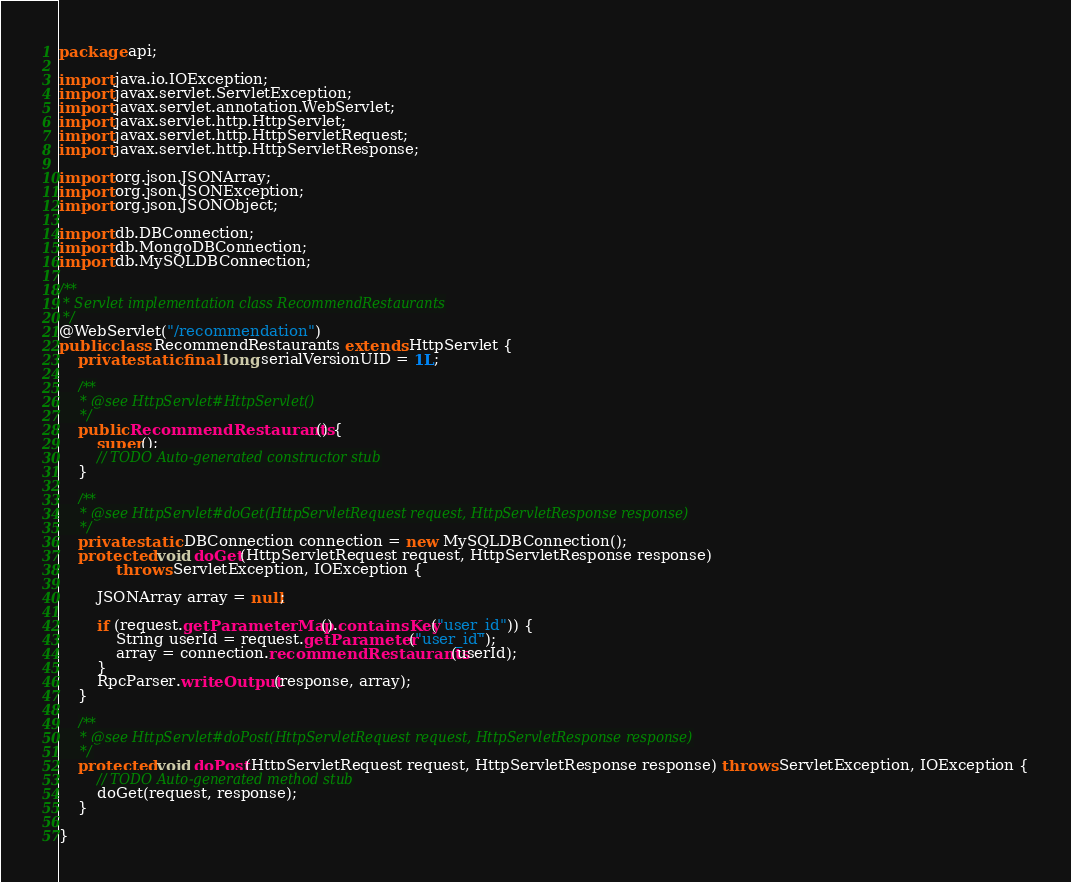Convert code to text. <code><loc_0><loc_0><loc_500><loc_500><_Java_>package api;

import java.io.IOException;
import javax.servlet.ServletException;
import javax.servlet.annotation.WebServlet;
import javax.servlet.http.HttpServlet;
import javax.servlet.http.HttpServletRequest;
import javax.servlet.http.HttpServletResponse;

import org.json.JSONArray;
import org.json.JSONException;
import org.json.JSONObject;

import db.DBConnection;
import db.MongoDBConnection;
import db.MySQLDBConnection;

/**
 * Servlet implementation class RecommendRestaurants
 */
@WebServlet("/recommendation")
public class RecommendRestaurants extends HttpServlet {
	private static final long serialVersionUID = 1L;
       
    /**
     * @see HttpServlet#HttpServlet()
     */
    public RecommendRestaurants() {
        super();
        // TODO Auto-generated constructor stub
    }

	/**
	 * @see HttpServlet#doGet(HttpServletRequest request, HttpServletResponse response)
	 */
    private static DBConnection connection = new MySQLDBConnection();
    protected void doGet(HttpServletRequest request, HttpServletResponse response)
			throws ServletException, IOException {
		
		JSONArray array = null;
		
		if (request.getParameterMap().containsKey("user_id")) {
			String userId = request.getParameter("user_id");
			array = connection.recommendRestaurants(userId);
		}
		RpcParser.writeOutput(response, array);
	}

	/**
	 * @see HttpServlet#doPost(HttpServletRequest request, HttpServletResponse response)
	 */
	protected void doPost(HttpServletRequest request, HttpServletResponse response) throws ServletException, IOException {
		// TODO Auto-generated method stub
		doGet(request, response);
	}

}
</code> 